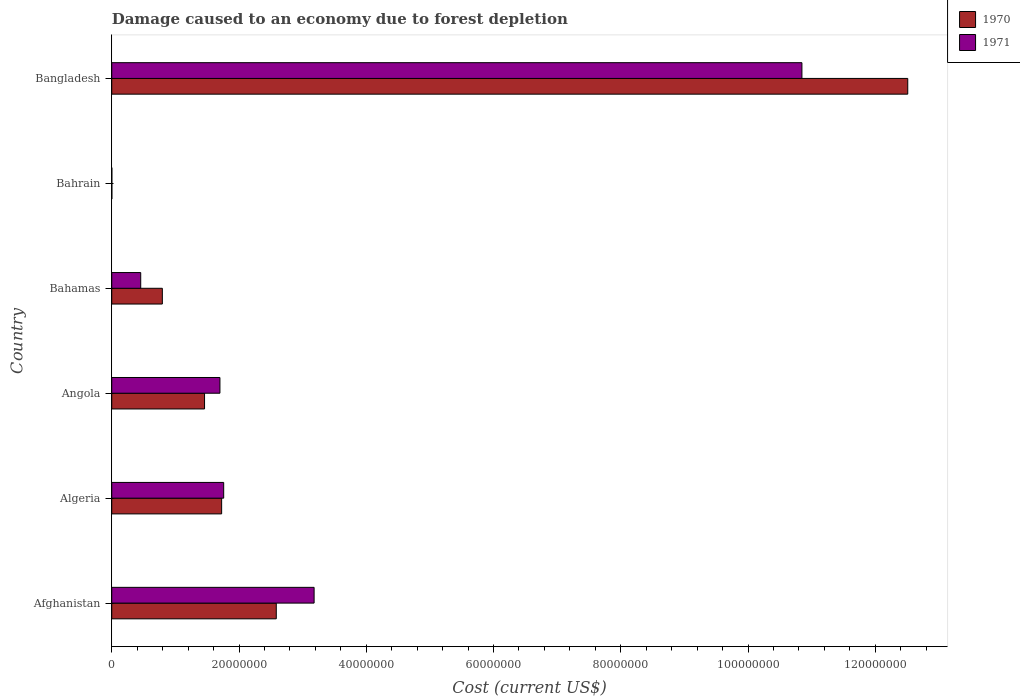How many bars are there on the 2nd tick from the top?
Your answer should be very brief. 2. How many bars are there on the 6th tick from the bottom?
Provide a short and direct response. 2. In how many cases, is the number of bars for a given country not equal to the number of legend labels?
Your answer should be compact. 0. What is the cost of damage caused due to forest depletion in 1971 in Bahrain?
Keep it short and to the point. 1.16e+04. Across all countries, what is the maximum cost of damage caused due to forest depletion in 1971?
Make the answer very short. 1.08e+08. Across all countries, what is the minimum cost of damage caused due to forest depletion in 1970?
Your response must be concise. 1.53e+04. In which country was the cost of damage caused due to forest depletion in 1970 minimum?
Offer a very short reply. Bahrain. What is the total cost of damage caused due to forest depletion in 1970 in the graph?
Offer a terse response. 1.91e+08. What is the difference between the cost of damage caused due to forest depletion in 1971 in Angola and that in Bangladesh?
Your response must be concise. -9.15e+07. What is the difference between the cost of damage caused due to forest depletion in 1970 in Bangladesh and the cost of damage caused due to forest depletion in 1971 in Afghanistan?
Offer a terse response. 9.33e+07. What is the average cost of damage caused due to forest depletion in 1970 per country?
Your response must be concise. 3.18e+07. What is the difference between the cost of damage caused due to forest depletion in 1971 and cost of damage caused due to forest depletion in 1970 in Bahrain?
Offer a terse response. -3638.2. What is the ratio of the cost of damage caused due to forest depletion in 1970 in Bahamas to that in Bahrain?
Your answer should be compact. 520.98. Is the difference between the cost of damage caused due to forest depletion in 1971 in Afghanistan and Algeria greater than the difference between the cost of damage caused due to forest depletion in 1970 in Afghanistan and Algeria?
Give a very brief answer. Yes. What is the difference between the highest and the second highest cost of damage caused due to forest depletion in 1971?
Provide a short and direct response. 7.67e+07. What is the difference between the highest and the lowest cost of damage caused due to forest depletion in 1970?
Provide a succinct answer. 1.25e+08. In how many countries, is the cost of damage caused due to forest depletion in 1970 greater than the average cost of damage caused due to forest depletion in 1970 taken over all countries?
Your answer should be compact. 1. What does the 2nd bar from the top in Bangladesh represents?
Ensure brevity in your answer.  1970. Are all the bars in the graph horizontal?
Provide a short and direct response. Yes. How many countries are there in the graph?
Offer a very short reply. 6. What is the difference between two consecutive major ticks on the X-axis?
Provide a succinct answer. 2.00e+07. Does the graph contain any zero values?
Offer a very short reply. No. Where does the legend appear in the graph?
Offer a terse response. Top right. What is the title of the graph?
Your answer should be compact. Damage caused to an economy due to forest depletion. Does "1972" appear as one of the legend labels in the graph?
Ensure brevity in your answer.  No. What is the label or title of the X-axis?
Your answer should be compact. Cost (current US$). What is the label or title of the Y-axis?
Your answer should be very brief. Country. What is the Cost (current US$) in 1970 in Afghanistan?
Provide a short and direct response. 2.59e+07. What is the Cost (current US$) of 1971 in Afghanistan?
Your answer should be compact. 3.18e+07. What is the Cost (current US$) in 1970 in Algeria?
Offer a terse response. 1.73e+07. What is the Cost (current US$) in 1971 in Algeria?
Provide a succinct answer. 1.76e+07. What is the Cost (current US$) of 1970 in Angola?
Give a very brief answer. 1.46e+07. What is the Cost (current US$) in 1971 in Angola?
Provide a short and direct response. 1.70e+07. What is the Cost (current US$) in 1970 in Bahamas?
Provide a short and direct response. 7.95e+06. What is the Cost (current US$) of 1971 in Bahamas?
Your response must be concise. 4.55e+06. What is the Cost (current US$) of 1970 in Bahrain?
Provide a succinct answer. 1.53e+04. What is the Cost (current US$) in 1971 in Bahrain?
Make the answer very short. 1.16e+04. What is the Cost (current US$) of 1970 in Bangladesh?
Provide a short and direct response. 1.25e+08. What is the Cost (current US$) in 1971 in Bangladesh?
Provide a short and direct response. 1.08e+08. Across all countries, what is the maximum Cost (current US$) in 1970?
Offer a very short reply. 1.25e+08. Across all countries, what is the maximum Cost (current US$) in 1971?
Ensure brevity in your answer.  1.08e+08. Across all countries, what is the minimum Cost (current US$) of 1970?
Ensure brevity in your answer.  1.53e+04. Across all countries, what is the minimum Cost (current US$) of 1971?
Your response must be concise. 1.16e+04. What is the total Cost (current US$) in 1970 in the graph?
Your response must be concise. 1.91e+08. What is the total Cost (current US$) in 1971 in the graph?
Provide a short and direct response. 1.79e+08. What is the difference between the Cost (current US$) in 1970 in Afghanistan and that in Algeria?
Your answer should be compact. 8.59e+06. What is the difference between the Cost (current US$) in 1971 in Afghanistan and that in Algeria?
Make the answer very short. 1.42e+07. What is the difference between the Cost (current US$) of 1970 in Afghanistan and that in Angola?
Your response must be concise. 1.13e+07. What is the difference between the Cost (current US$) in 1971 in Afghanistan and that in Angola?
Provide a succinct answer. 1.48e+07. What is the difference between the Cost (current US$) in 1970 in Afghanistan and that in Bahamas?
Your answer should be compact. 1.79e+07. What is the difference between the Cost (current US$) in 1971 in Afghanistan and that in Bahamas?
Give a very brief answer. 2.73e+07. What is the difference between the Cost (current US$) of 1970 in Afghanistan and that in Bahrain?
Your answer should be very brief. 2.58e+07. What is the difference between the Cost (current US$) of 1971 in Afghanistan and that in Bahrain?
Provide a short and direct response. 3.18e+07. What is the difference between the Cost (current US$) in 1970 in Afghanistan and that in Bangladesh?
Offer a terse response. -9.92e+07. What is the difference between the Cost (current US$) of 1971 in Afghanistan and that in Bangladesh?
Provide a short and direct response. -7.67e+07. What is the difference between the Cost (current US$) of 1970 in Algeria and that in Angola?
Your answer should be very brief. 2.69e+06. What is the difference between the Cost (current US$) of 1971 in Algeria and that in Angola?
Provide a succinct answer. 5.88e+05. What is the difference between the Cost (current US$) in 1970 in Algeria and that in Bahamas?
Keep it short and to the point. 9.32e+06. What is the difference between the Cost (current US$) in 1971 in Algeria and that in Bahamas?
Your answer should be very brief. 1.30e+07. What is the difference between the Cost (current US$) in 1970 in Algeria and that in Bahrain?
Your answer should be very brief. 1.73e+07. What is the difference between the Cost (current US$) in 1971 in Algeria and that in Bahrain?
Your response must be concise. 1.76e+07. What is the difference between the Cost (current US$) of 1970 in Algeria and that in Bangladesh?
Give a very brief answer. -1.08e+08. What is the difference between the Cost (current US$) in 1971 in Algeria and that in Bangladesh?
Provide a succinct answer. -9.09e+07. What is the difference between the Cost (current US$) in 1970 in Angola and that in Bahamas?
Your answer should be compact. 6.63e+06. What is the difference between the Cost (current US$) in 1971 in Angola and that in Bahamas?
Give a very brief answer. 1.25e+07. What is the difference between the Cost (current US$) of 1970 in Angola and that in Bahrain?
Your response must be concise. 1.46e+07. What is the difference between the Cost (current US$) in 1971 in Angola and that in Bahrain?
Your answer should be very brief. 1.70e+07. What is the difference between the Cost (current US$) in 1970 in Angola and that in Bangladesh?
Your answer should be very brief. -1.11e+08. What is the difference between the Cost (current US$) in 1971 in Angola and that in Bangladesh?
Ensure brevity in your answer.  -9.15e+07. What is the difference between the Cost (current US$) in 1970 in Bahamas and that in Bahrain?
Ensure brevity in your answer.  7.94e+06. What is the difference between the Cost (current US$) in 1971 in Bahamas and that in Bahrain?
Keep it short and to the point. 4.54e+06. What is the difference between the Cost (current US$) of 1970 in Bahamas and that in Bangladesh?
Offer a very short reply. -1.17e+08. What is the difference between the Cost (current US$) of 1971 in Bahamas and that in Bangladesh?
Offer a very short reply. -1.04e+08. What is the difference between the Cost (current US$) in 1970 in Bahrain and that in Bangladesh?
Offer a terse response. -1.25e+08. What is the difference between the Cost (current US$) of 1971 in Bahrain and that in Bangladesh?
Your response must be concise. -1.08e+08. What is the difference between the Cost (current US$) in 1970 in Afghanistan and the Cost (current US$) in 1971 in Algeria?
Provide a short and direct response. 8.27e+06. What is the difference between the Cost (current US$) in 1970 in Afghanistan and the Cost (current US$) in 1971 in Angola?
Offer a very short reply. 8.85e+06. What is the difference between the Cost (current US$) in 1970 in Afghanistan and the Cost (current US$) in 1971 in Bahamas?
Provide a short and direct response. 2.13e+07. What is the difference between the Cost (current US$) in 1970 in Afghanistan and the Cost (current US$) in 1971 in Bahrain?
Your answer should be very brief. 2.58e+07. What is the difference between the Cost (current US$) of 1970 in Afghanistan and the Cost (current US$) of 1971 in Bangladesh?
Keep it short and to the point. -8.26e+07. What is the difference between the Cost (current US$) in 1970 in Algeria and the Cost (current US$) in 1971 in Angola?
Your response must be concise. 2.66e+05. What is the difference between the Cost (current US$) of 1970 in Algeria and the Cost (current US$) of 1971 in Bahamas?
Ensure brevity in your answer.  1.27e+07. What is the difference between the Cost (current US$) of 1970 in Algeria and the Cost (current US$) of 1971 in Bahrain?
Give a very brief answer. 1.73e+07. What is the difference between the Cost (current US$) in 1970 in Algeria and the Cost (current US$) in 1971 in Bangladesh?
Give a very brief answer. -9.12e+07. What is the difference between the Cost (current US$) in 1970 in Angola and the Cost (current US$) in 1971 in Bahamas?
Your response must be concise. 1.00e+07. What is the difference between the Cost (current US$) of 1970 in Angola and the Cost (current US$) of 1971 in Bahrain?
Offer a terse response. 1.46e+07. What is the difference between the Cost (current US$) in 1970 in Angola and the Cost (current US$) in 1971 in Bangladesh?
Provide a short and direct response. -9.39e+07. What is the difference between the Cost (current US$) of 1970 in Bahamas and the Cost (current US$) of 1971 in Bahrain?
Your answer should be very brief. 7.94e+06. What is the difference between the Cost (current US$) in 1970 in Bahamas and the Cost (current US$) in 1971 in Bangladesh?
Offer a terse response. -1.01e+08. What is the difference between the Cost (current US$) in 1970 in Bahrain and the Cost (current US$) in 1971 in Bangladesh?
Ensure brevity in your answer.  -1.08e+08. What is the average Cost (current US$) in 1970 per country?
Your answer should be compact. 3.18e+07. What is the average Cost (current US$) in 1971 per country?
Provide a short and direct response. 2.99e+07. What is the difference between the Cost (current US$) in 1970 and Cost (current US$) in 1971 in Afghanistan?
Keep it short and to the point. -5.95e+06. What is the difference between the Cost (current US$) in 1970 and Cost (current US$) in 1971 in Algeria?
Provide a succinct answer. -3.23e+05. What is the difference between the Cost (current US$) of 1970 and Cost (current US$) of 1971 in Angola?
Provide a succinct answer. -2.42e+06. What is the difference between the Cost (current US$) of 1970 and Cost (current US$) of 1971 in Bahamas?
Provide a succinct answer. 3.40e+06. What is the difference between the Cost (current US$) of 1970 and Cost (current US$) of 1971 in Bahrain?
Your answer should be compact. 3638.2. What is the difference between the Cost (current US$) in 1970 and Cost (current US$) in 1971 in Bangladesh?
Offer a very short reply. 1.66e+07. What is the ratio of the Cost (current US$) in 1970 in Afghanistan to that in Algeria?
Give a very brief answer. 1.5. What is the ratio of the Cost (current US$) in 1971 in Afghanistan to that in Algeria?
Keep it short and to the point. 1.81. What is the ratio of the Cost (current US$) of 1970 in Afghanistan to that in Angola?
Your answer should be compact. 1.77. What is the ratio of the Cost (current US$) in 1971 in Afghanistan to that in Angola?
Keep it short and to the point. 1.87. What is the ratio of the Cost (current US$) in 1970 in Afghanistan to that in Bahamas?
Keep it short and to the point. 3.25. What is the ratio of the Cost (current US$) of 1971 in Afghanistan to that in Bahamas?
Your response must be concise. 6.99. What is the ratio of the Cost (current US$) in 1970 in Afghanistan to that in Bahrain?
Your answer should be very brief. 1694.06. What is the ratio of the Cost (current US$) in 1971 in Afghanistan to that in Bahrain?
Give a very brief answer. 2735.57. What is the ratio of the Cost (current US$) in 1970 in Afghanistan to that in Bangladesh?
Your response must be concise. 0.21. What is the ratio of the Cost (current US$) of 1971 in Afghanistan to that in Bangladesh?
Provide a succinct answer. 0.29. What is the ratio of the Cost (current US$) in 1970 in Algeria to that in Angola?
Provide a succinct answer. 1.18. What is the ratio of the Cost (current US$) of 1971 in Algeria to that in Angola?
Offer a terse response. 1.03. What is the ratio of the Cost (current US$) in 1970 in Algeria to that in Bahamas?
Provide a short and direct response. 2.17. What is the ratio of the Cost (current US$) in 1971 in Algeria to that in Bahamas?
Offer a very short reply. 3.86. What is the ratio of the Cost (current US$) in 1970 in Algeria to that in Bahrain?
Give a very brief answer. 1131.46. What is the ratio of the Cost (current US$) in 1971 in Algeria to that in Bahrain?
Make the answer very short. 1513.28. What is the ratio of the Cost (current US$) of 1970 in Algeria to that in Bangladesh?
Your response must be concise. 0.14. What is the ratio of the Cost (current US$) of 1971 in Algeria to that in Bangladesh?
Make the answer very short. 0.16. What is the ratio of the Cost (current US$) of 1970 in Angola to that in Bahamas?
Make the answer very short. 1.83. What is the ratio of the Cost (current US$) in 1971 in Angola to that in Bahamas?
Offer a very short reply. 3.73. What is the ratio of the Cost (current US$) in 1970 in Angola to that in Bahrain?
Keep it short and to the point. 955.55. What is the ratio of the Cost (current US$) in 1971 in Angola to that in Bahrain?
Make the answer very short. 1462.67. What is the ratio of the Cost (current US$) of 1970 in Angola to that in Bangladesh?
Provide a short and direct response. 0.12. What is the ratio of the Cost (current US$) in 1971 in Angola to that in Bangladesh?
Provide a short and direct response. 0.16. What is the ratio of the Cost (current US$) in 1970 in Bahamas to that in Bahrain?
Ensure brevity in your answer.  520.98. What is the ratio of the Cost (current US$) of 1971 in Bahamas to that in Bahrain?
Give a very brief answer. 391.63. What is the ratio of the Cost (current US$) in 1970 in Bahamas to that in Bangladesh?
Offer a very short reply. 0.06. What is the ratio of the Cost (current US$) in 1971 in Bahamas to that in Bangladesh?
Offer a terse response. 0.04. What is the ratio of the Cost (current US$) in 1970 in Bahrain to that in Bangladesh?
Give a very brief answer. 0. What is the difference between the highest and the second highest Cost (current US$) of 1970?
Your answer should be very brief. 9.92e+07. What is the difference between the highest and the second highest Cost (current US$) in 1971?
Ensure brevity in your answer.  7.67e+07. What is the difference between the highest and the lowest Cost (current US$) in 1970?
Make the answer very short. 1.25e+08. What is the difference between the highest and the lowest Cost (current US$) of 1971?
Offer a very short reply. 1.08e+08. 